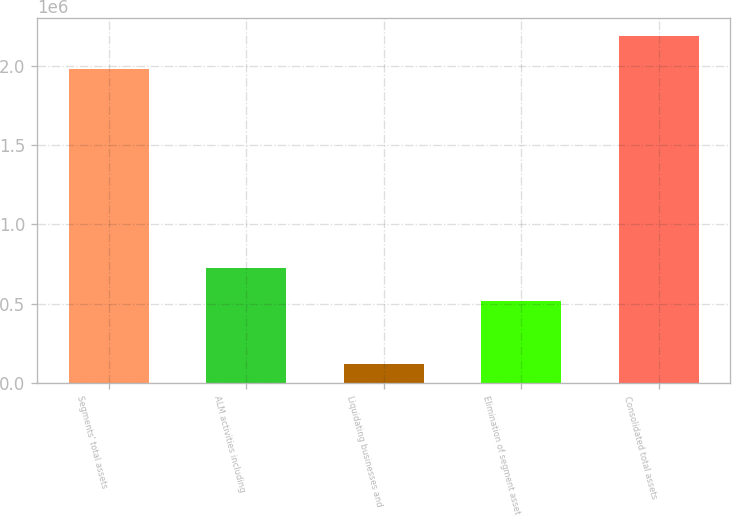Convert chart to OTSL. <chart><loc_0><loc_0><loc_500><loc_500><bar_chart><fcel>Segments' total assets<fcel>ALM activities including<fcel>Liquidating businesses and<fcel>Elimination of segment asset<fcel>Consolidated total assets<nl><fcel>1.97565e+06<fcel>725655<fcel>118073<fcel>518656<fcel>2.18807e+06<nl></chart> 